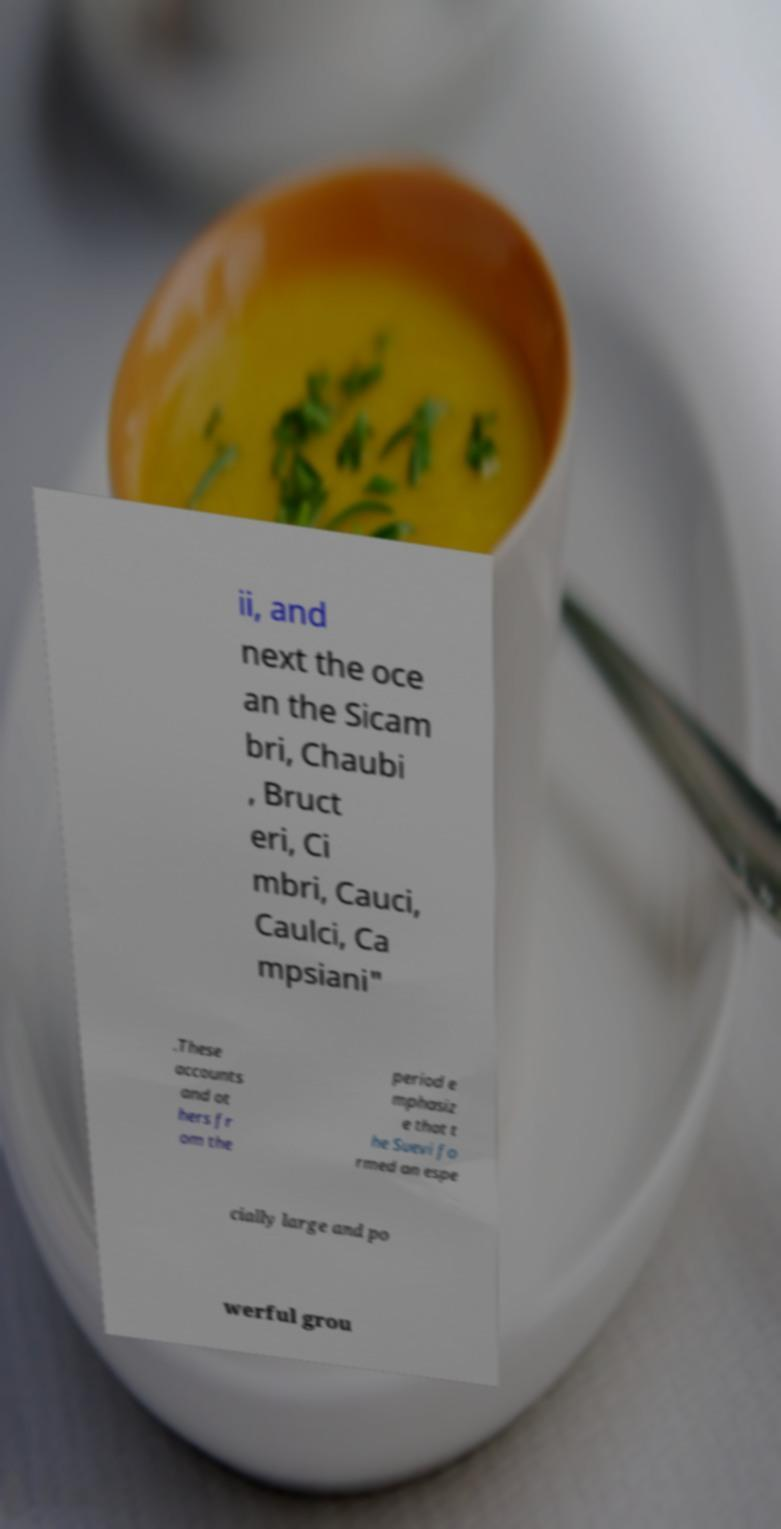Can you accurately transcribe the text from the provided image for me? ii, and next the oce an the Sicam bri, Chaubi , Bruct eri, Ci mbri, Cauci, Caulci, Ca mpsiani" .These accounts and ot hers fr om the period e mphasiz e that t he Suevi fo rmed an espe cially large and po werful grou 